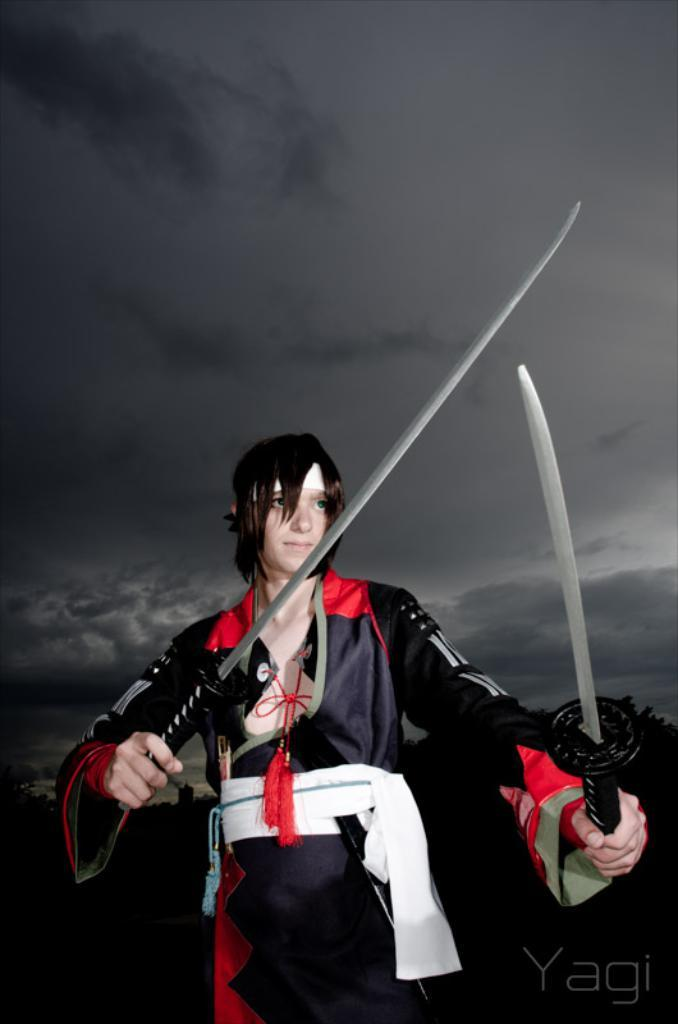What type of image is being described? The image is animated. Can you describe the character in the image? There is a man in the image, and he is wearing a black and red dress. What is the man holding in his hands? The man is holding swords in his hands. What can be seen in the background of the image? There is a sky visible in the background of the image. Where is the sheet and shelf located in the image? There is no sheet or shelf present in the image. Who is the writer in the image? There is no writer present in the image. 